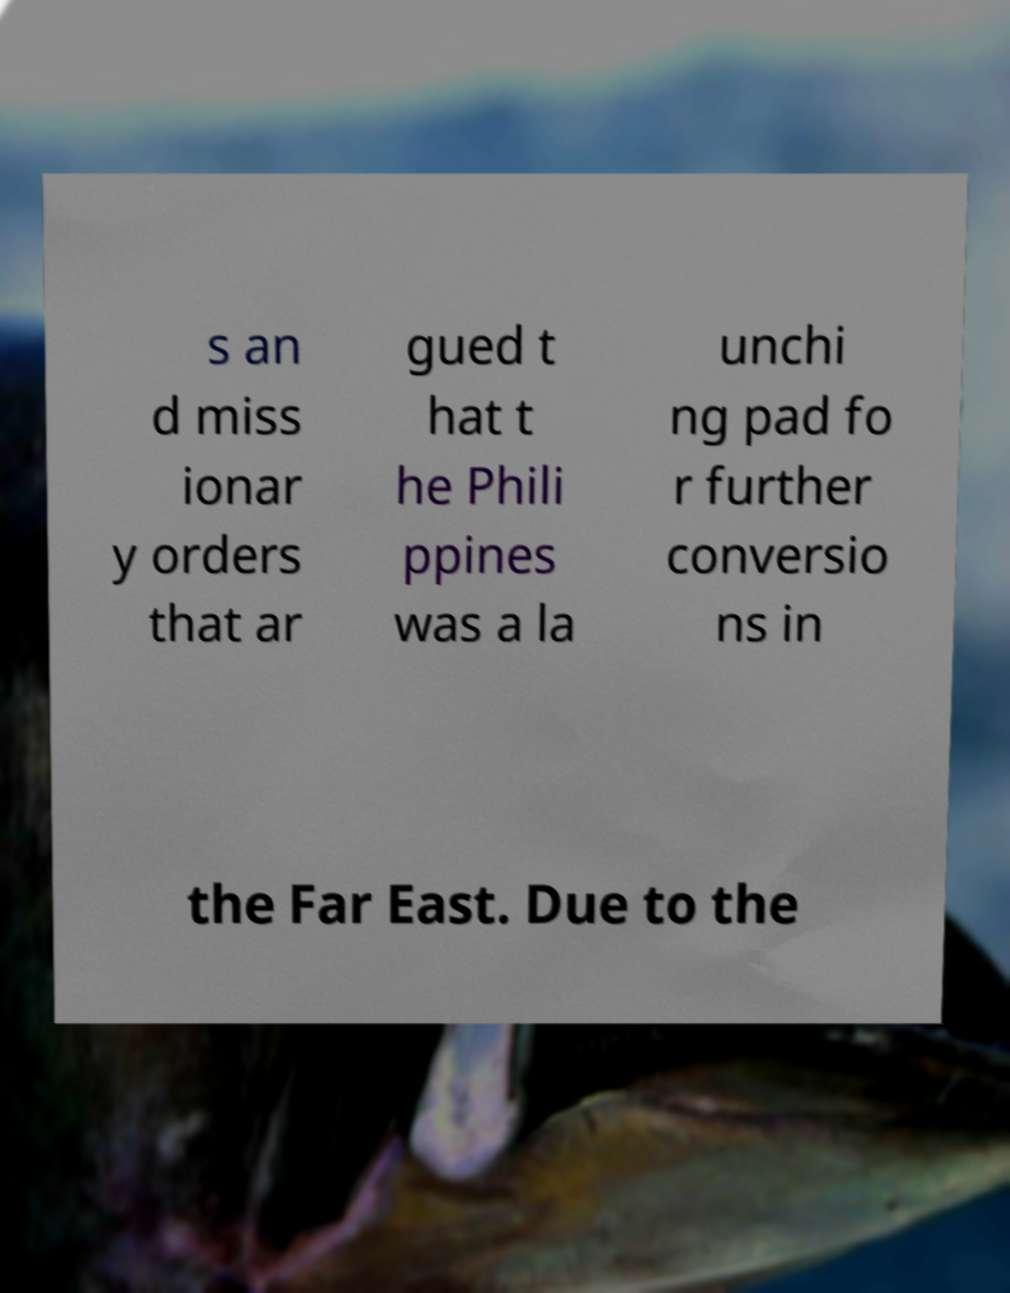What messages or text are displayed in this image? I need them in a readable, typed format. s an d miss ionar y orders that ar gued t hat t he Phili ppines was a la unchi ng pad fo r further conversio ns in the Far East. Due to the 